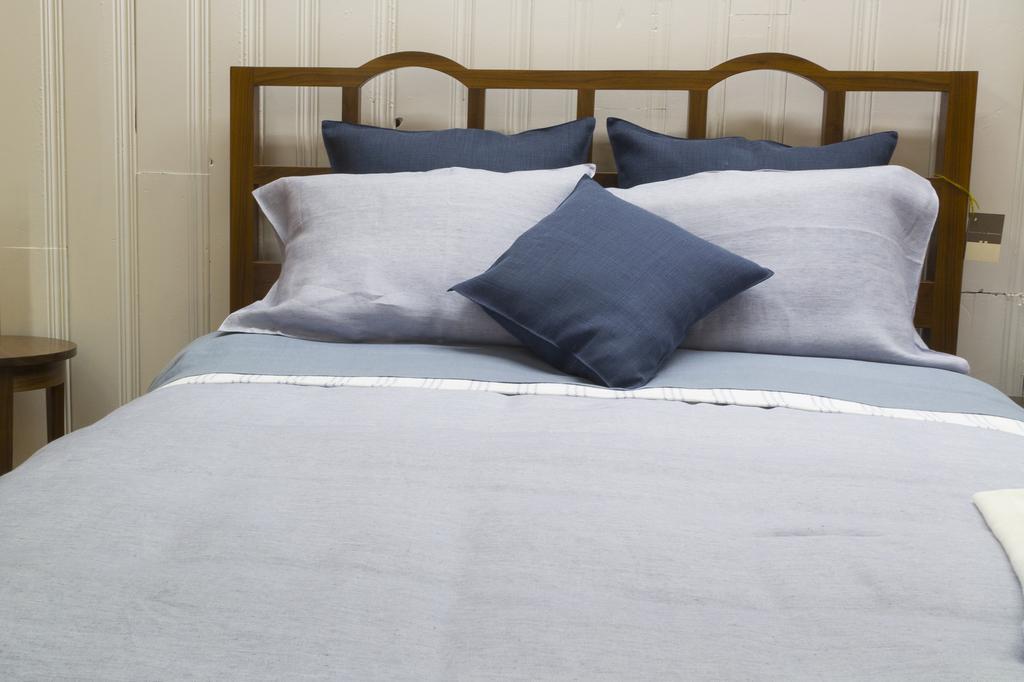Could you give a brief overview of what you see in this image? The picture is taken inside a room. In the middle there is a bed. On the bed there is a blue bed cover there are some pillows on the bed. There is a side table beside the bed. In the background there is a white wall. 